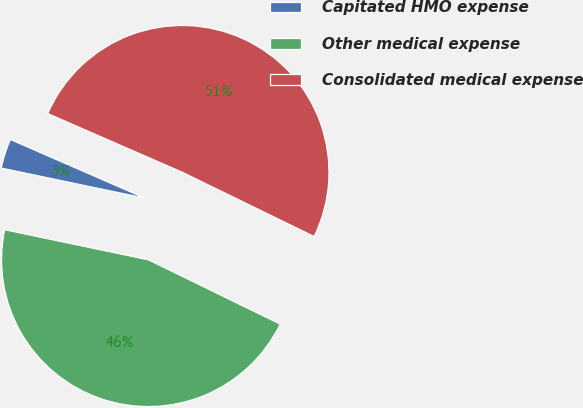Convert chart to OTSL. <chart><loc_0><loc_0><loc_500><loc_500><pie_chart><fcel>Capitated HMO expense<fcel>Other medical expense<fcel>Consolidated medical expense<nl><fcel>3.26%<fcel>46.07%<fcel>50.68%<nl></chart> 